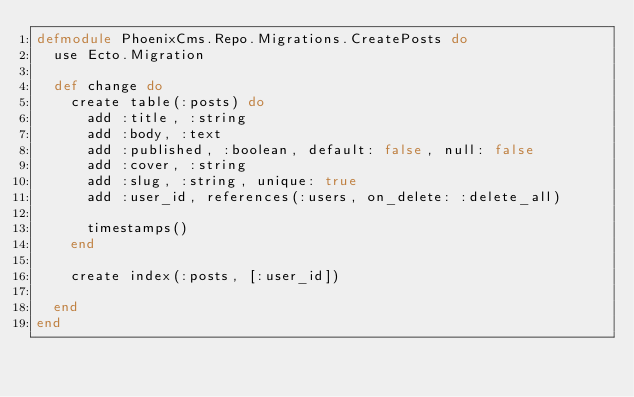Convert code to text. <code><loc_0><loc_0><loc_500><loc_500><_Elixir_>defmodule PhoenixCms.Repo.Migrations.CreatePosts do
  use Ecto.Migration

  def change do
    create table(:posts) do
      add :title, :string
      add :body, :text
      add :published, :boolean, default: false, null: false
      add :cover, :string
      add :slug, :string, unique: true
      add :user_id, references(:users, on_delete: :delete_all)

      timestamps()
    end

    create index(:posts, [:user_id])

  end
end
</code> 